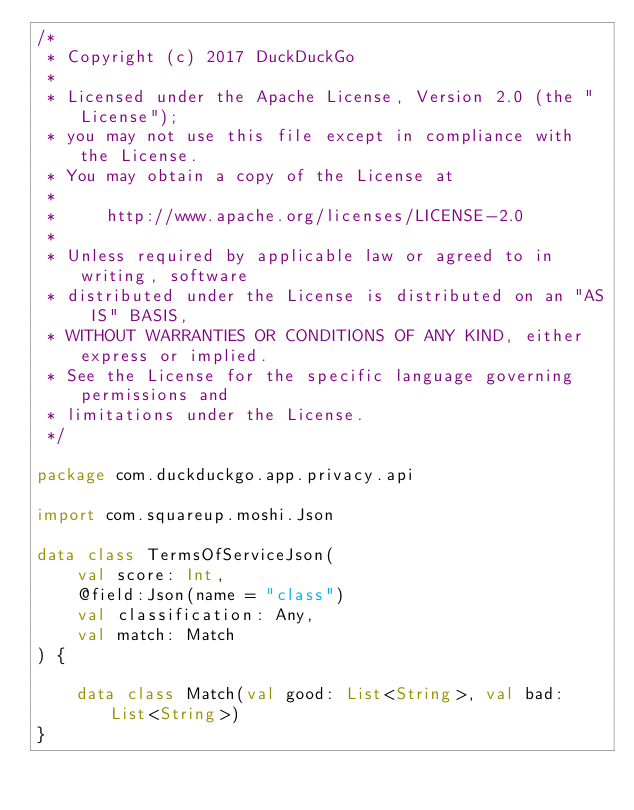Convert code to text. <code><loc_0><loc_0><loc_500><loc_500><_Kotlin_>/*
 * Copyright (c) 2017 DuckDuckGo
 *
 * Licensed under the Apache License, Version 2.0 (the "License");
 * you may not use this file except in compliance with the License.
 * You may obtain a copy of the License at
 *
 *     http://www.apache.org/licenses/LICENSE-2.0
 *
 * Unless required by applicable law or agreed to in writing, software
 * distributed under the License is distributed on an "AS IS" BASIS,
 * WITHOUT WARRANTIES OR CONDITIONS OF ANY KIND, either express or implied.
 * See the License for the specific language governing permissions and
 * limitations under the License.
 */

package com.duckduckgo.app.privacy.api

import com.squareup.moshi.Json

data class TermsOfServiceJson(
    val score: Int,
    @field:Json(name = "class")
    val classification: Any,
    val match: Match
) {

    data class Match(val good: List<String>, val bad: List<String>)
}
</code> 